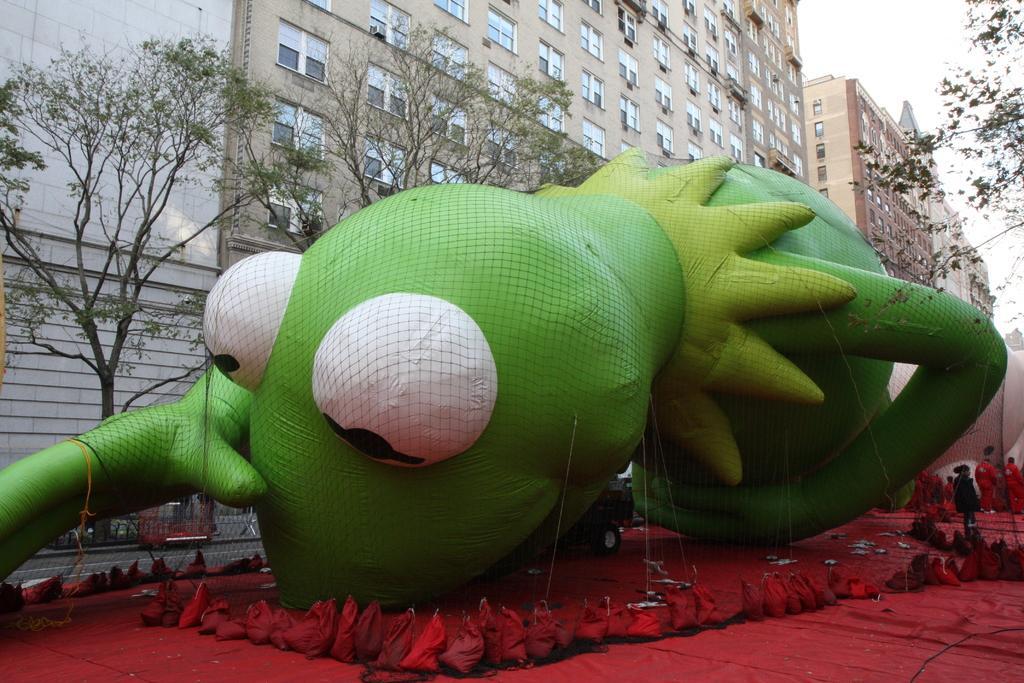Describe this image in one or two sentences. In this image we can see a big air balloon tied with ropes is placed on the ground with carpets. Here we can see the net and people standing here. In the background, we can see the road, buildings and sky. 